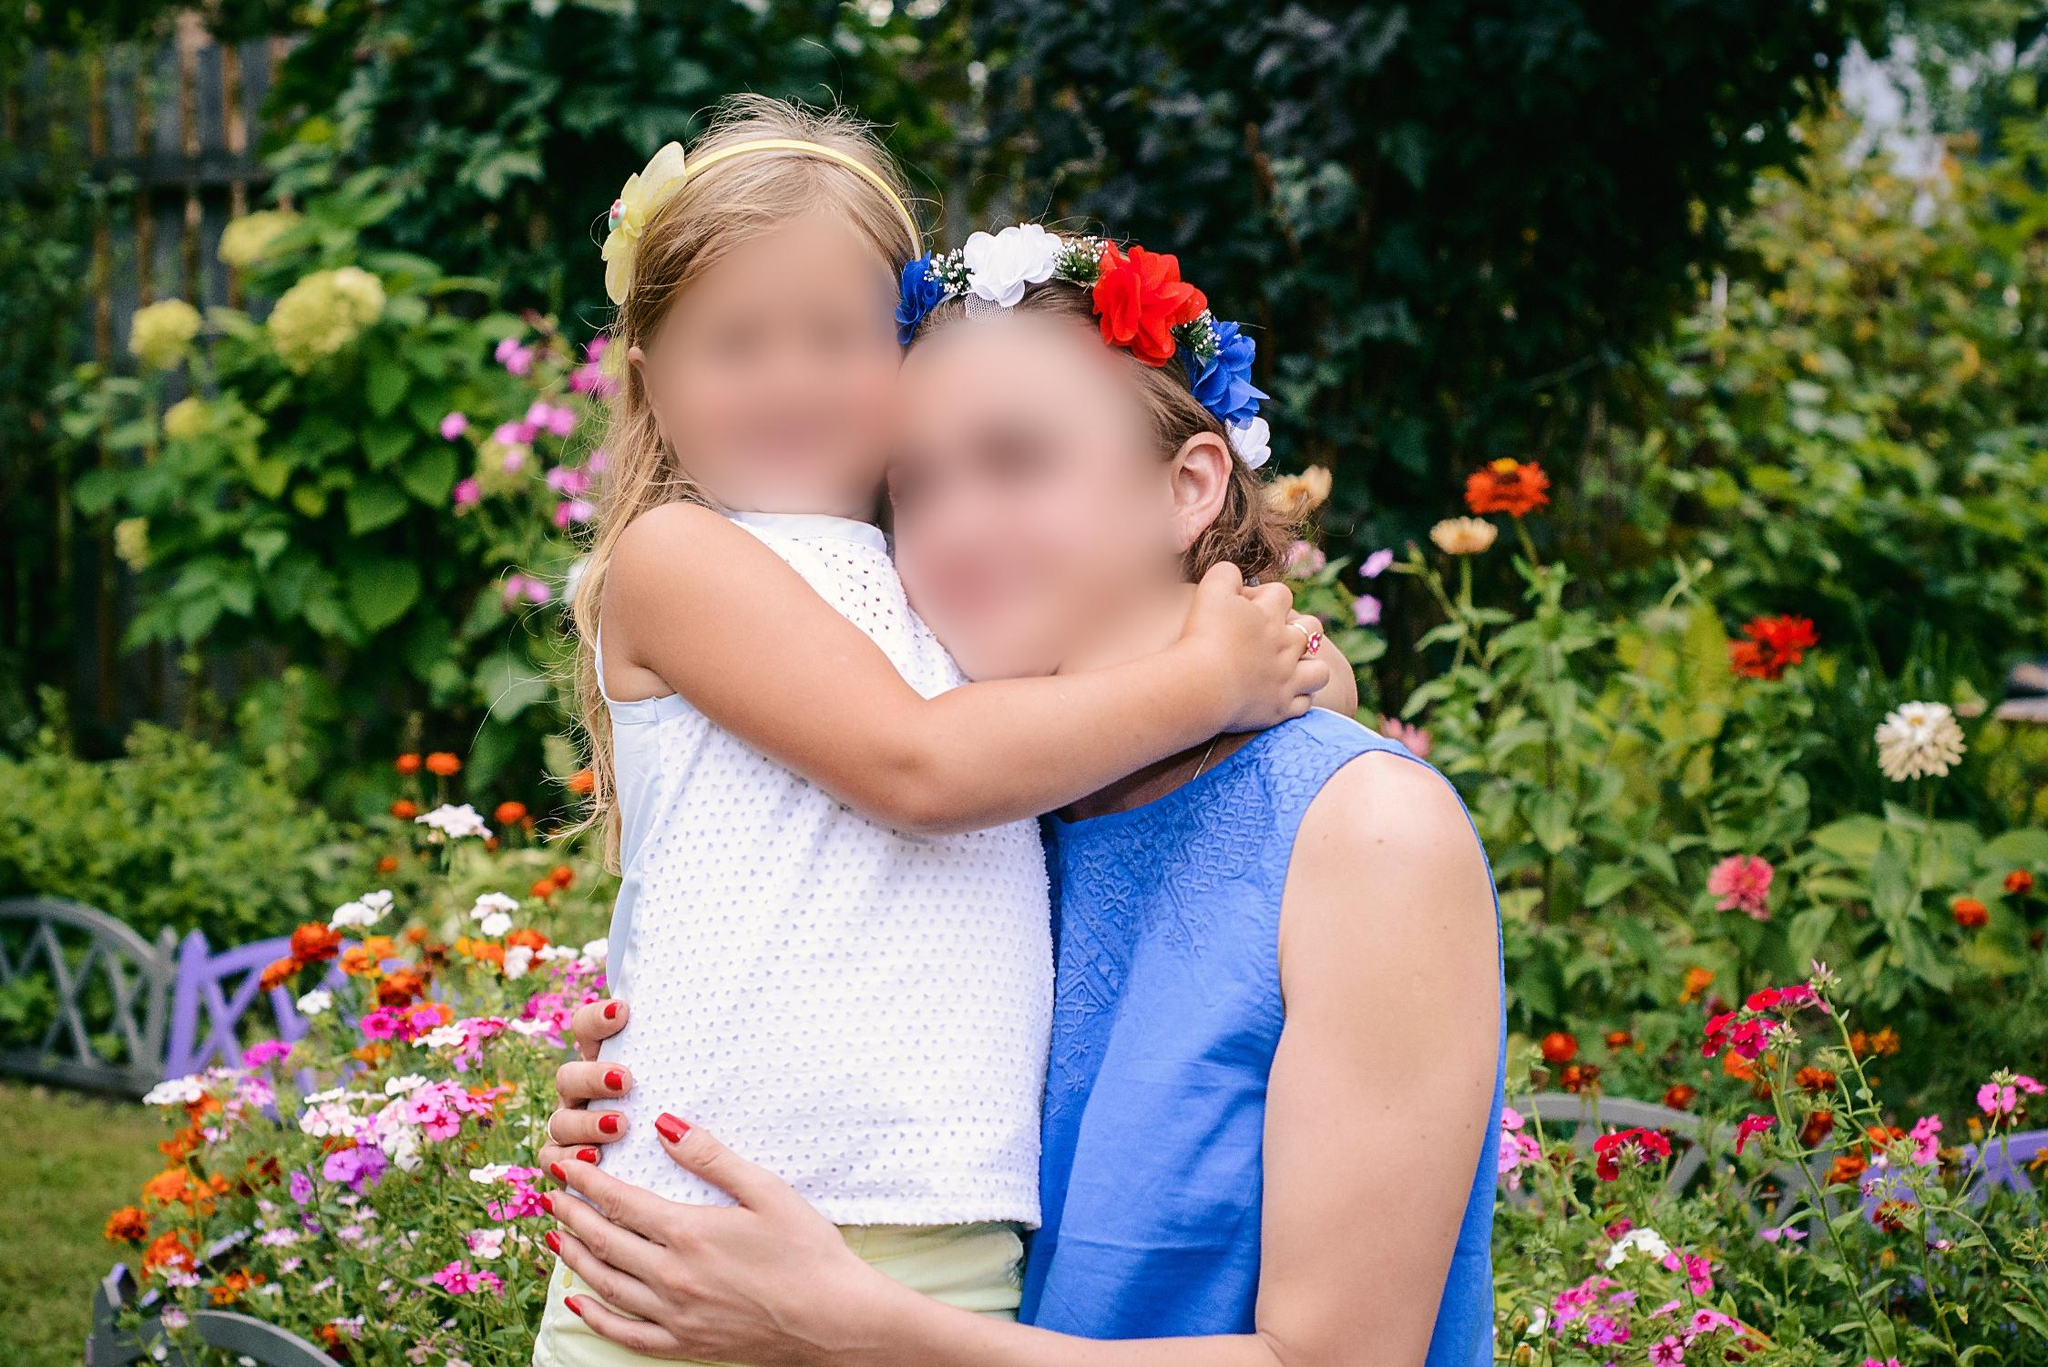What do you see happening in this image?
 The image captures a heartwarming moment between two individuals in a lush garden. The person on the left, clad in a white top, is locked in an embrace with the person on the right, who is wearing a blue top adorned with a flower crown. The garden around them is a riot of colors, with vibrant flowers and verdant greenery creating a picturesque backdrop. The photo is taken from a slightly elevated perspective, adding depth to the scene and highlighting the intimacy of the moment shared between the two individuals. The overall composition of the image suggests a serene and joyful atmosphere. 